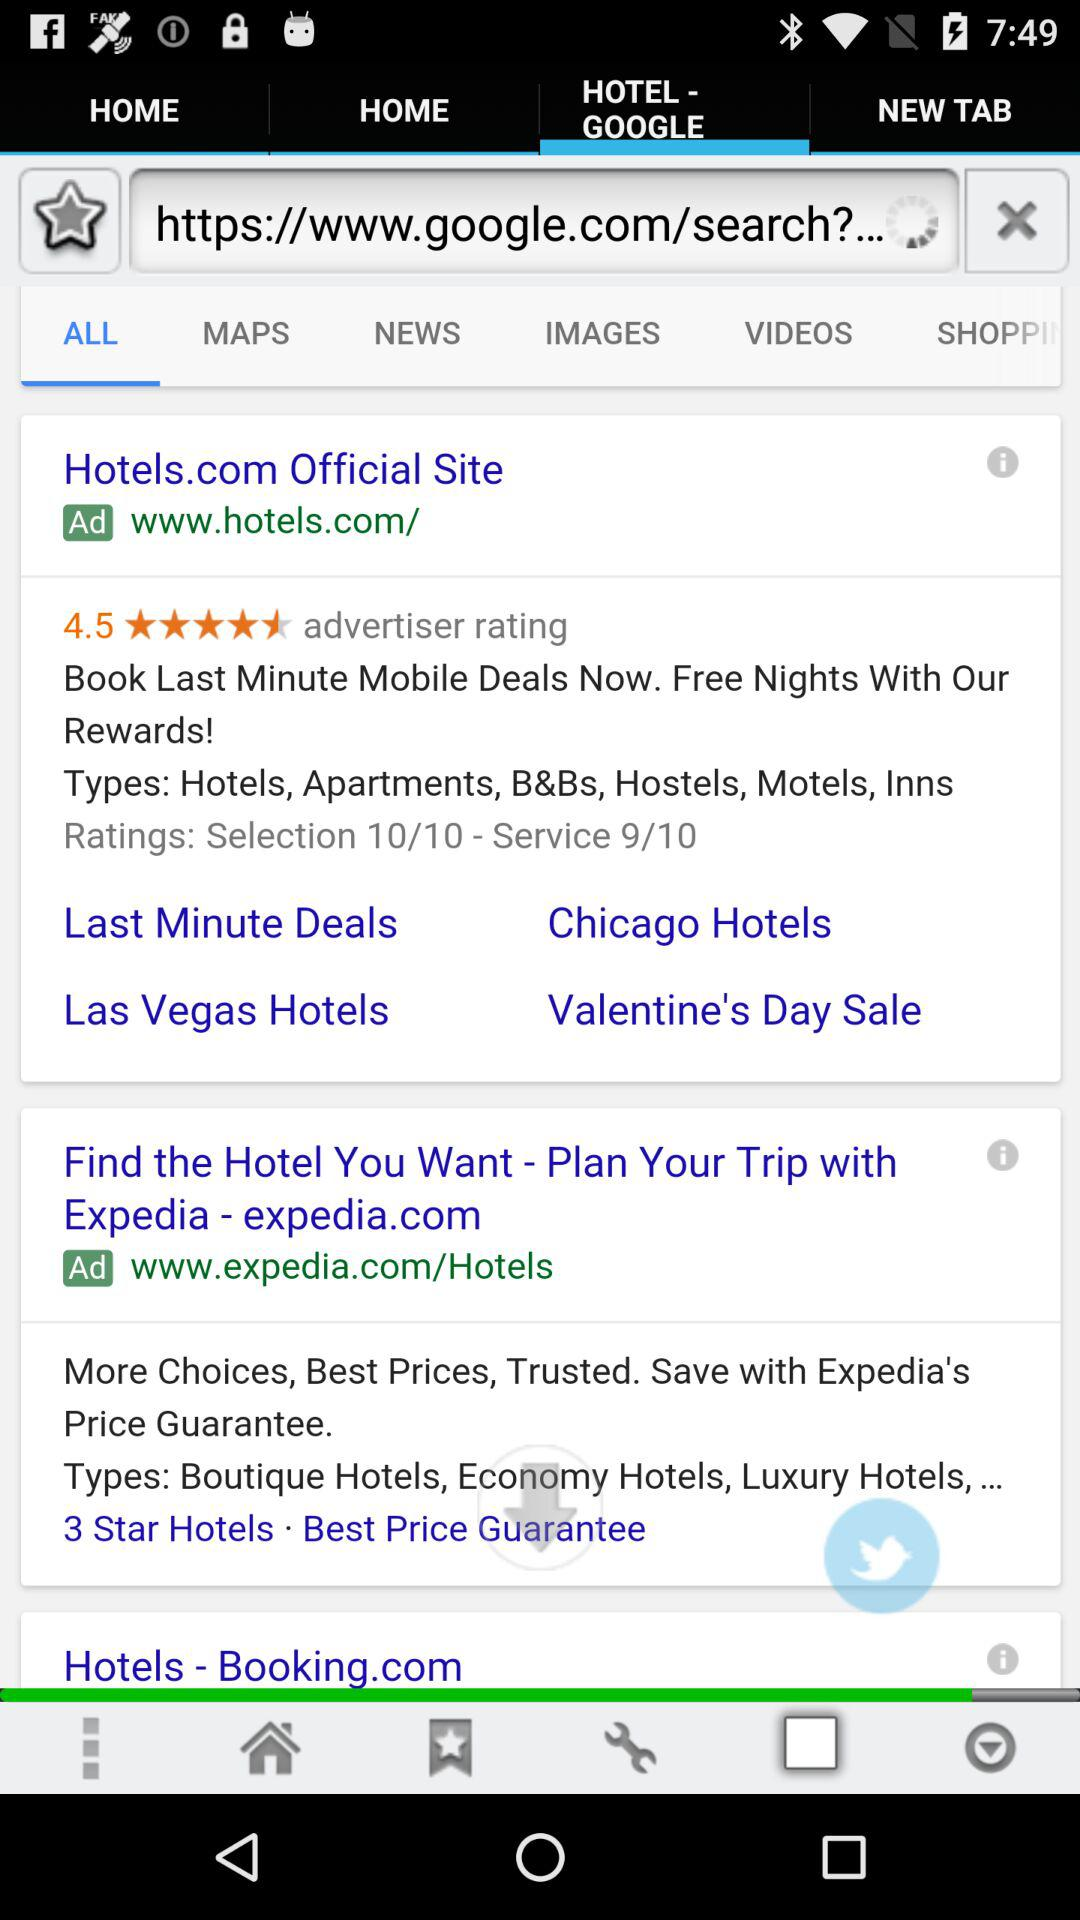What is the advertiser rating? The advertiser rating is 4.5. 